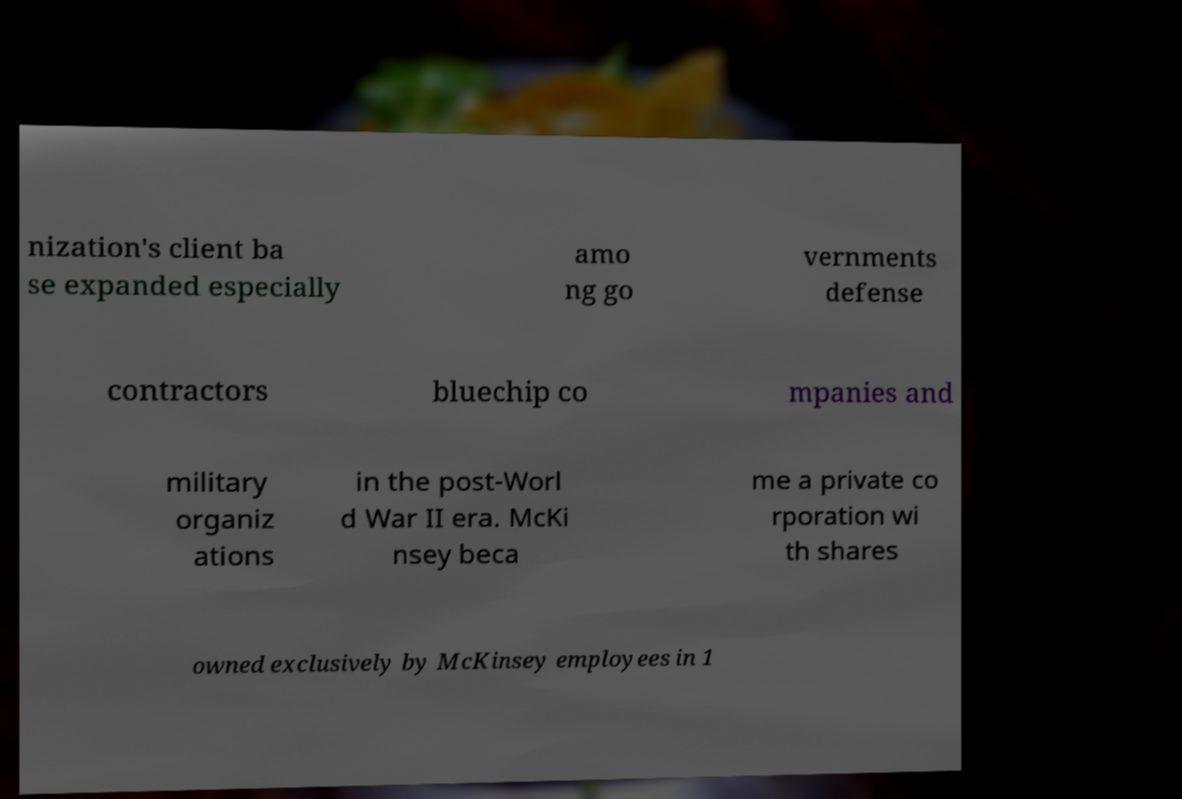For documentation purposes, I need the text within this image transcribed. Could you provide that? nization's client ba se expanded especially amo ng go vernments defense contractors bluechip co mpanies and military organiz ations in the post-Worl d War II era. McKi nsey beca me a private co rporation wi th shares owned exclusively by McKinsey employees in 1 